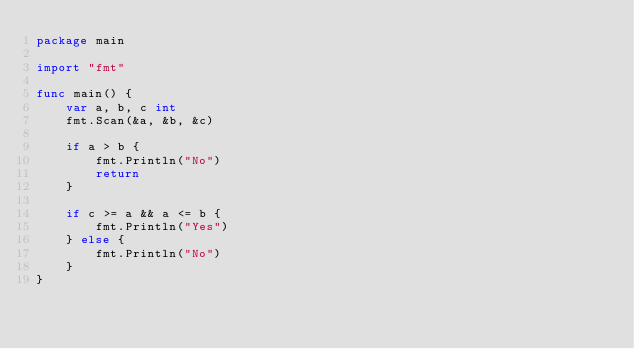Convert code to text. <code><loc_0><loc_0><loc_500><loc_500><_Go_>package main

import "fmt"

func main() {
	var a, b, c int
	fmt.Scan(&a, &b, &c)

	if a > b {
		fmt.Println("No")
		return
	}

	if c >= a && a <= b {
		fmt.Println("Yes")
	} else {
		fmt.Println("No")
	}
}
</code> 